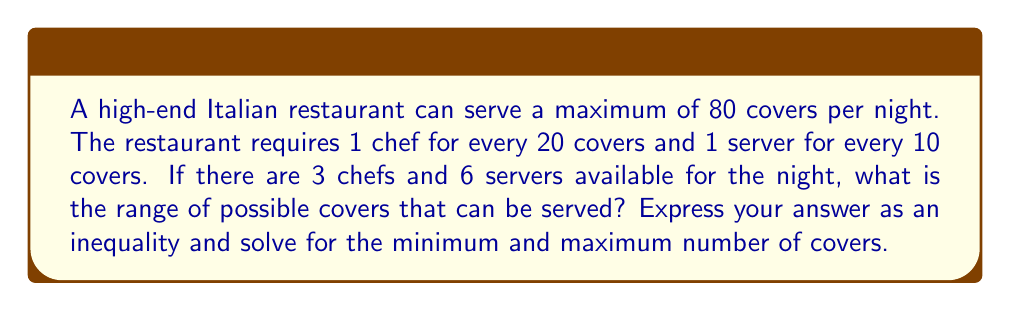What is the answer to this math problem? Let's approach this step-by-step:

1) Let $x$ be the number of covers served in a night.

2) Chef constraint:
   - 1 chef can handle 20 covers
   - 3 chefs can handle $3 \times 20 = 60$ covers
   - So, $x \leq 60$ based on chef availability

3) Server constraint:
   - 1 server can handle 10 covers
   - 6 servers can handle $6 \times 10 = 60$ covers
   - So, $x \leq 60$ based on server availability

4) Restaurant maximum capacity:
   - The restaurant can serve a maximum of 80 covers
   - So, $x \leq 80$

5) Combining all constraints:
   $x \leq \min(60, 60, 80) = 60$

6) The minimum number of covers is 0 (theoretically, they could choose not to serve anyone)

7) Therefore, the inequality is:
   $0 \leq x \leq 60$

8) The minimum number of covers is 0, and the maximum is 60.
Answer: $0 \leq x \leq 60$; Min: 0, Max: 60 